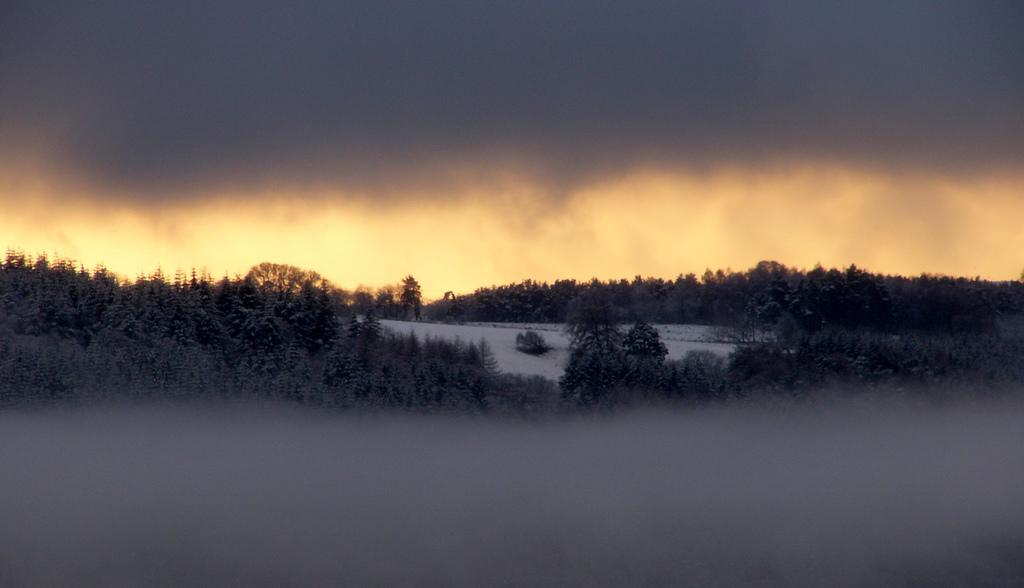What type of vegetation can be seen in the image? There are trees in the image. What is the weather like in the image? There is snow visible in the image, indicating a cold and likely snowy environment. What is the condition of the sky in the background? The sky in the background is cloudy. How many sheep are present at the event in the image? There are no sheep or events present in the image; it features trees, snow, and a cloudy sky. 